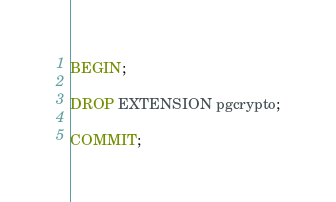Convert code to text. <code><loc_0><loc_0><loc_500><loc_500><_SQL_>
BEGIN;

DROP EXTENSION pgcrypto;

COMMIT;
</code> 